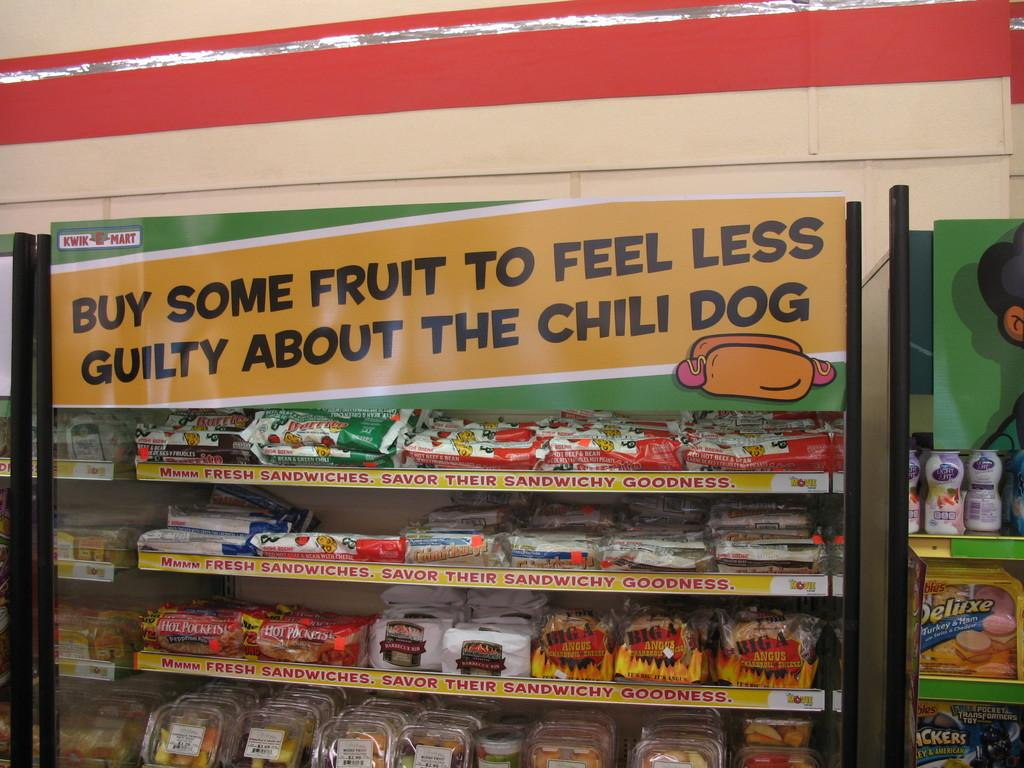<image>
Offer a succinct explanation of the picture presented. A grocery display that says buy some fruit to feel less guilty about the chili dog. 